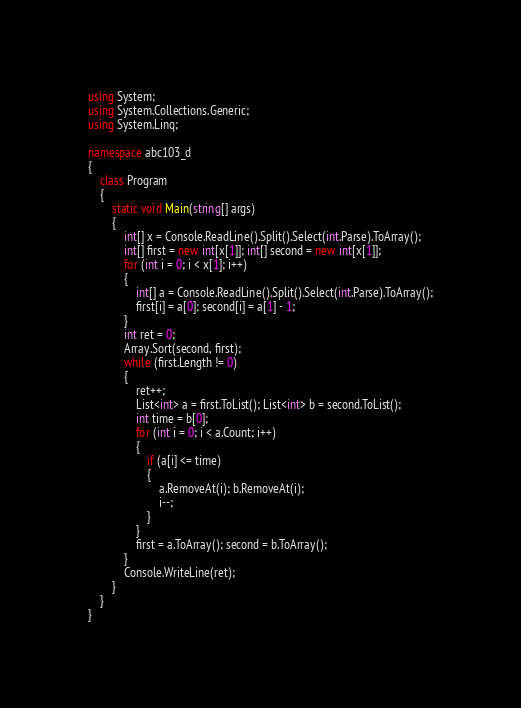Convert code to text. <code><loc_0><loc_0><loc_500><loc_500><_C#_>using System;
using System.Collections.Generic;
using System.Linq;

namespace abc103_d
{
	class Program
	{
		static void Main(string[] args)
		{
			int[] x = Console.ReadLine().Split().Select(int.Parse).ToArray();
			int[] first = new int[x[1]]; int[] second = new int[x[1]];
			for (int i = 0; i < x[1]; i++)
			{
				int[] a = Console.ReadLine().Split().Select(int.Parse).ToArray();
				first[i] = a[0]; second[i] = a[1] - 1;
			}
			int ret = 0;
			Array.Sort(second, first);
			while (first.Length != 0)
			{
				ret++;
				List<int> a = first.ToList(); List<int> b = second.ToList();
				int time = b[0];
				for (int i = 0; i < a.Count; i++)
				{
					if (a[i] <= time)
					{
						a.RemoveAt(i); b.RemoveAt(i);
						i--;
					}
				}
				first = a.ToArray(); second = b.ToArray();
			}
			Console.WriteLine(ret);
		}
	}
}</code> 